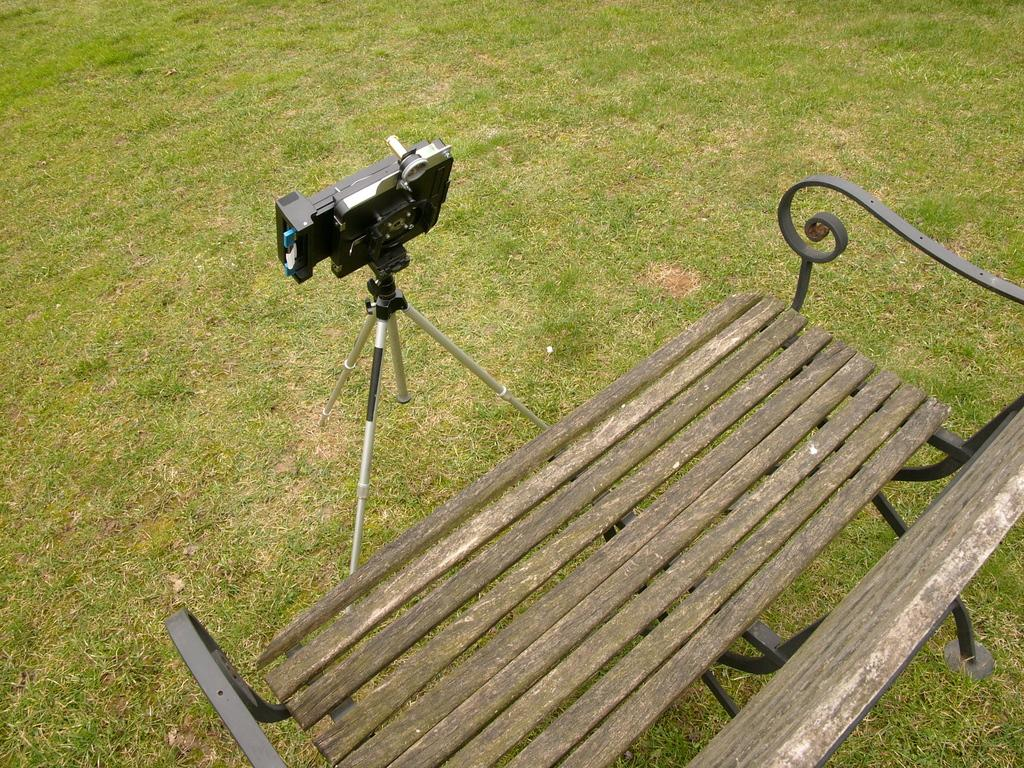What is the main object in the image? There is a camera in the image. How is the camera positioned in the image? The camera is fixed to a tripod. What type of surface is visible on the ground? There is a wooden bench and grass on the ground. What type of breakfast is being prepared on the wooden bench in the image? There is no breakfast or any indication of food preparation in the image. 